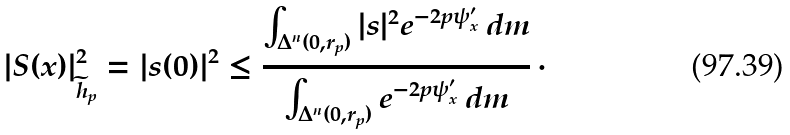Convert formula to latex. <formula><loc_0><loc_0><loc_500><loc_500>| S ( x ) | ^ { 2 } _ { \widetilde { h } _ { p } } = | s ( 0 ) | ^ { 2 } \leq \frac { \int _ { \Delta ^ { n } ( 0 , r _ { p } ) } | s | ^ { 2 } e ^ { - 2 p \psi ^ { \prime } _ { x } } \, d m } { \int _ { \Delta ^ { n } ( 0 , r _ { p } ) } e ^ { - 2 p \psi ^ { \prime } _ { x } } \, d m } \, \cdot</formula> 